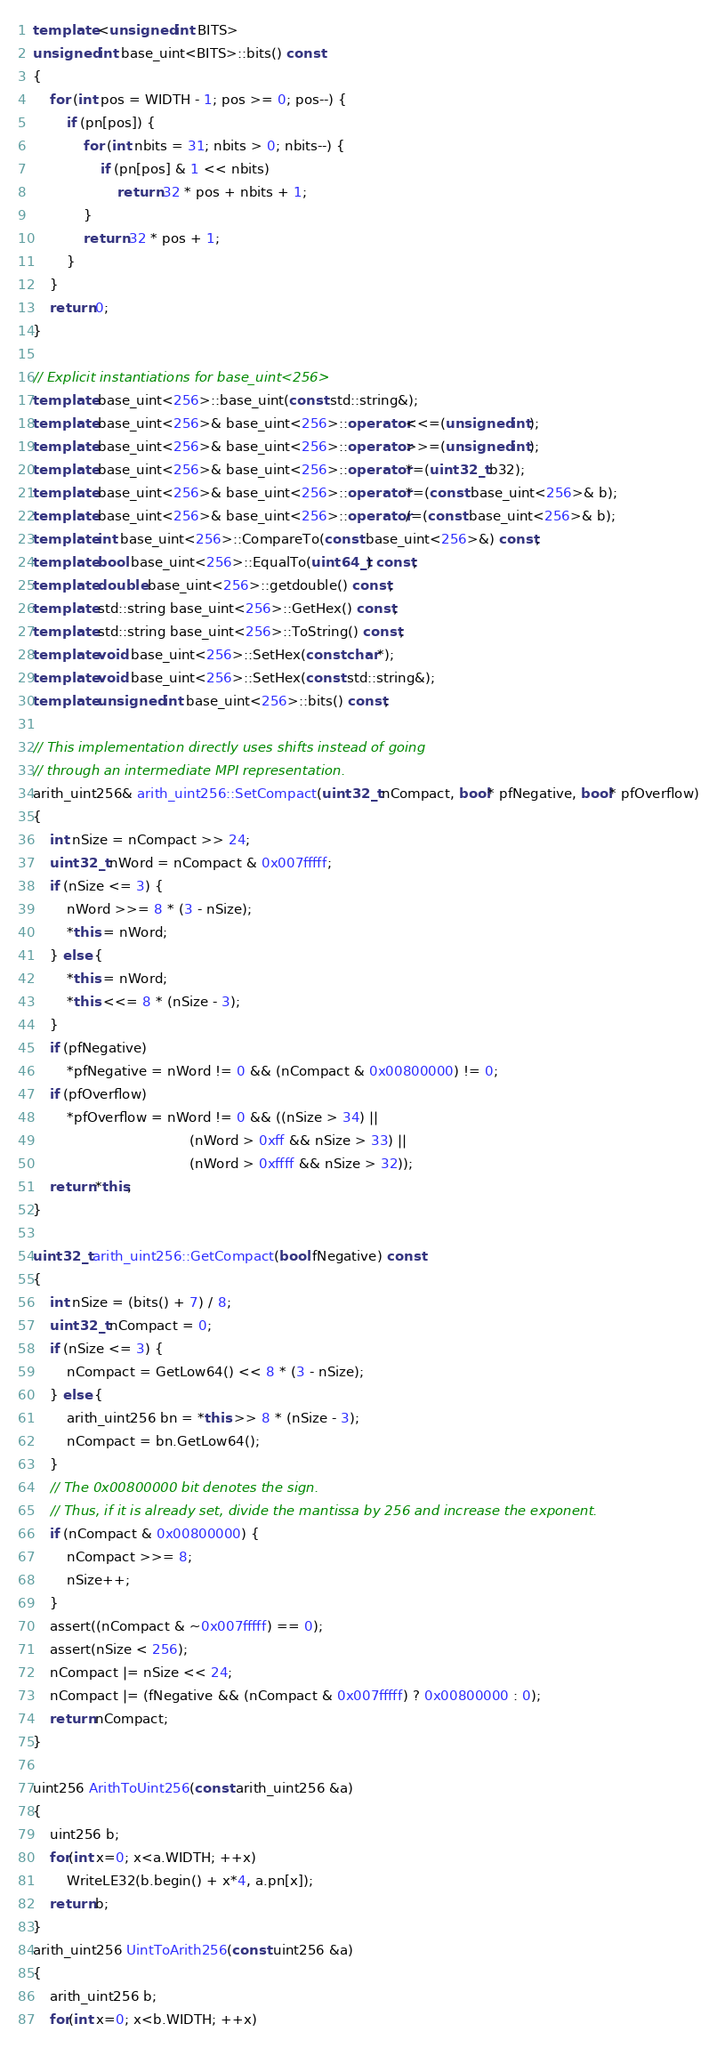Convert code to text. <code><loc_0><loc_0><loc_500><loc_500><_C++_>
template <unsigned int BITS>
unsigned int base_uint<BITS>::bits() const
{
    for (int pos = WIDTH - 1; pos >= 0; pos--) {
        if (pn[pos]) {
            for (int nbits = 31; nbits > 0; nbits--) {
                if (pn[pos] & 1 << nbits)
                    return 32 * pos + nbits + 1;
            }
            return 32 * pos + 1;
        }
    }
    return 0;
}

// Explicit instantiations for base_uint<256>
template base_uint<256>::base_uint(const std::string&);
template base_uint<256>& base_uint<256>::operator<<=(unsigned int);
template base_uint<256>& base_uint<256>::operator>>=(unsigned int);
template base_uint<256>& base_uint<256>::operator*=(uint32_t b32);
template base_uint<256>& base_uint<256>::operator*=(const base_uint<256>& b);
template base_uint<256>& base_uint<256>::operator/=(const base_uint<256>& b);
template int base_uint<256>::CompareTo(const base_uint<256>&) const;
template bool base_uint<256>::EqualTo(uint64_t) const;
template double base_uint<256>::getdouble() const;
template std::string base_uint<256>::GetHex() const;
template std::string base_uint<256>::ToString() const;
template void base_uint<256>::SetHex(const char*);
template void base_uint<256>::SetHex(const std::string&);
template unsigned int base_uint<256>::bits() const;

// This implementation directly uses shifts instead of going
// through an intermediate MPI representation.
arith_uint256& arith_uint256::SetCompact(uint32_t nCompact, bool* pfNegative, bool* pfOverflow)
{
    int nSize = nCompact >> 24;
    uint32_t nWord = nCompact & 0x007fffff;
    if (nSize <= 3) {
        nWord >>= 8 * (3 - nSize);
        *this = nWord;
    } else {
        *this = nWord;
        *this <<= 8 * (nSize - 3);
    }
    if (pfNegative)
        *pfNegative = nWord != 0 && (nCompact & 0x00800000) != 0;
    if (pfOverflow)
        *pfOverflow = nWord != 0 && ((nSize > 34) ||
                                     (nWord > 0xff && nSize > 33) ||
                                     (nWord > 0xffff && nSize > 32));
    return *this;
}

uint32_t arith_uint256::GetCompact(bool fNegative) const
{
    int nSize = (bits() + 7) / 8;
    uint32_t nCompact = 0;
    if (nSize <= 3) {
        nCompact = GetLow64() << 8 * (3 - nSize);
    } else {
        arith_uint256 bn = *this >> 8 * (nSize - 3);
        nCompact = bn.GetLow64();
    }
    // The 0x00800000 bit denotes the sign.
    // Thus, if it is already set, divide the mantissa by 256 and increase the exponent.
    if (nCompact & 0x00800000) {
        nCompact >>= 8;
        nSize++;
    }
    assert((nCompact & ~0x007fffff) == 0);
    assert(nSize < 256);
    nCompact |= nSize << 24;
    nCompact |= (fNegative && (nCompact & 0x007fffff) ? 0x00800000 : 0);
    return nCompact;
}

uint256 ArithToUint256(const arith_uint256 &a)
{
    uint256 b;
    for(int x=0; x<a.WIDTH; ++x)
        WriteLE32(b.begin() + x*4, a.pn[x]);
    return b;
}
arith_uint256 UintToArith256(const uint256 &a)
{
    arith_uint256 b;
    for(int x=0; x<b.WIDTH; ++x)</code> 